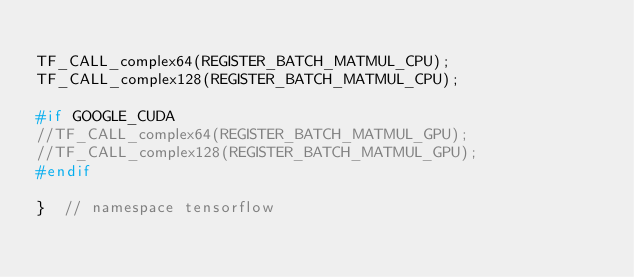<code> <loc_0><loc_0><loc_500><loc_500><_C++_>
TF_CALL_complex64(REGISTER_BATCH_MATMUL_CPU);
TF_CALL_complex128(REGISTER_BATCH_MATMUL_CPU);

#if GOOGLE_CUDA
//TF_CALL_complex64(REGISTER_BATCH_MATMUL_GPU);
//TF_CALL_complex128(REGISTER_BATCH_MATMUL_GPU);
#endif

}  // namespace tensorflow
</code> 